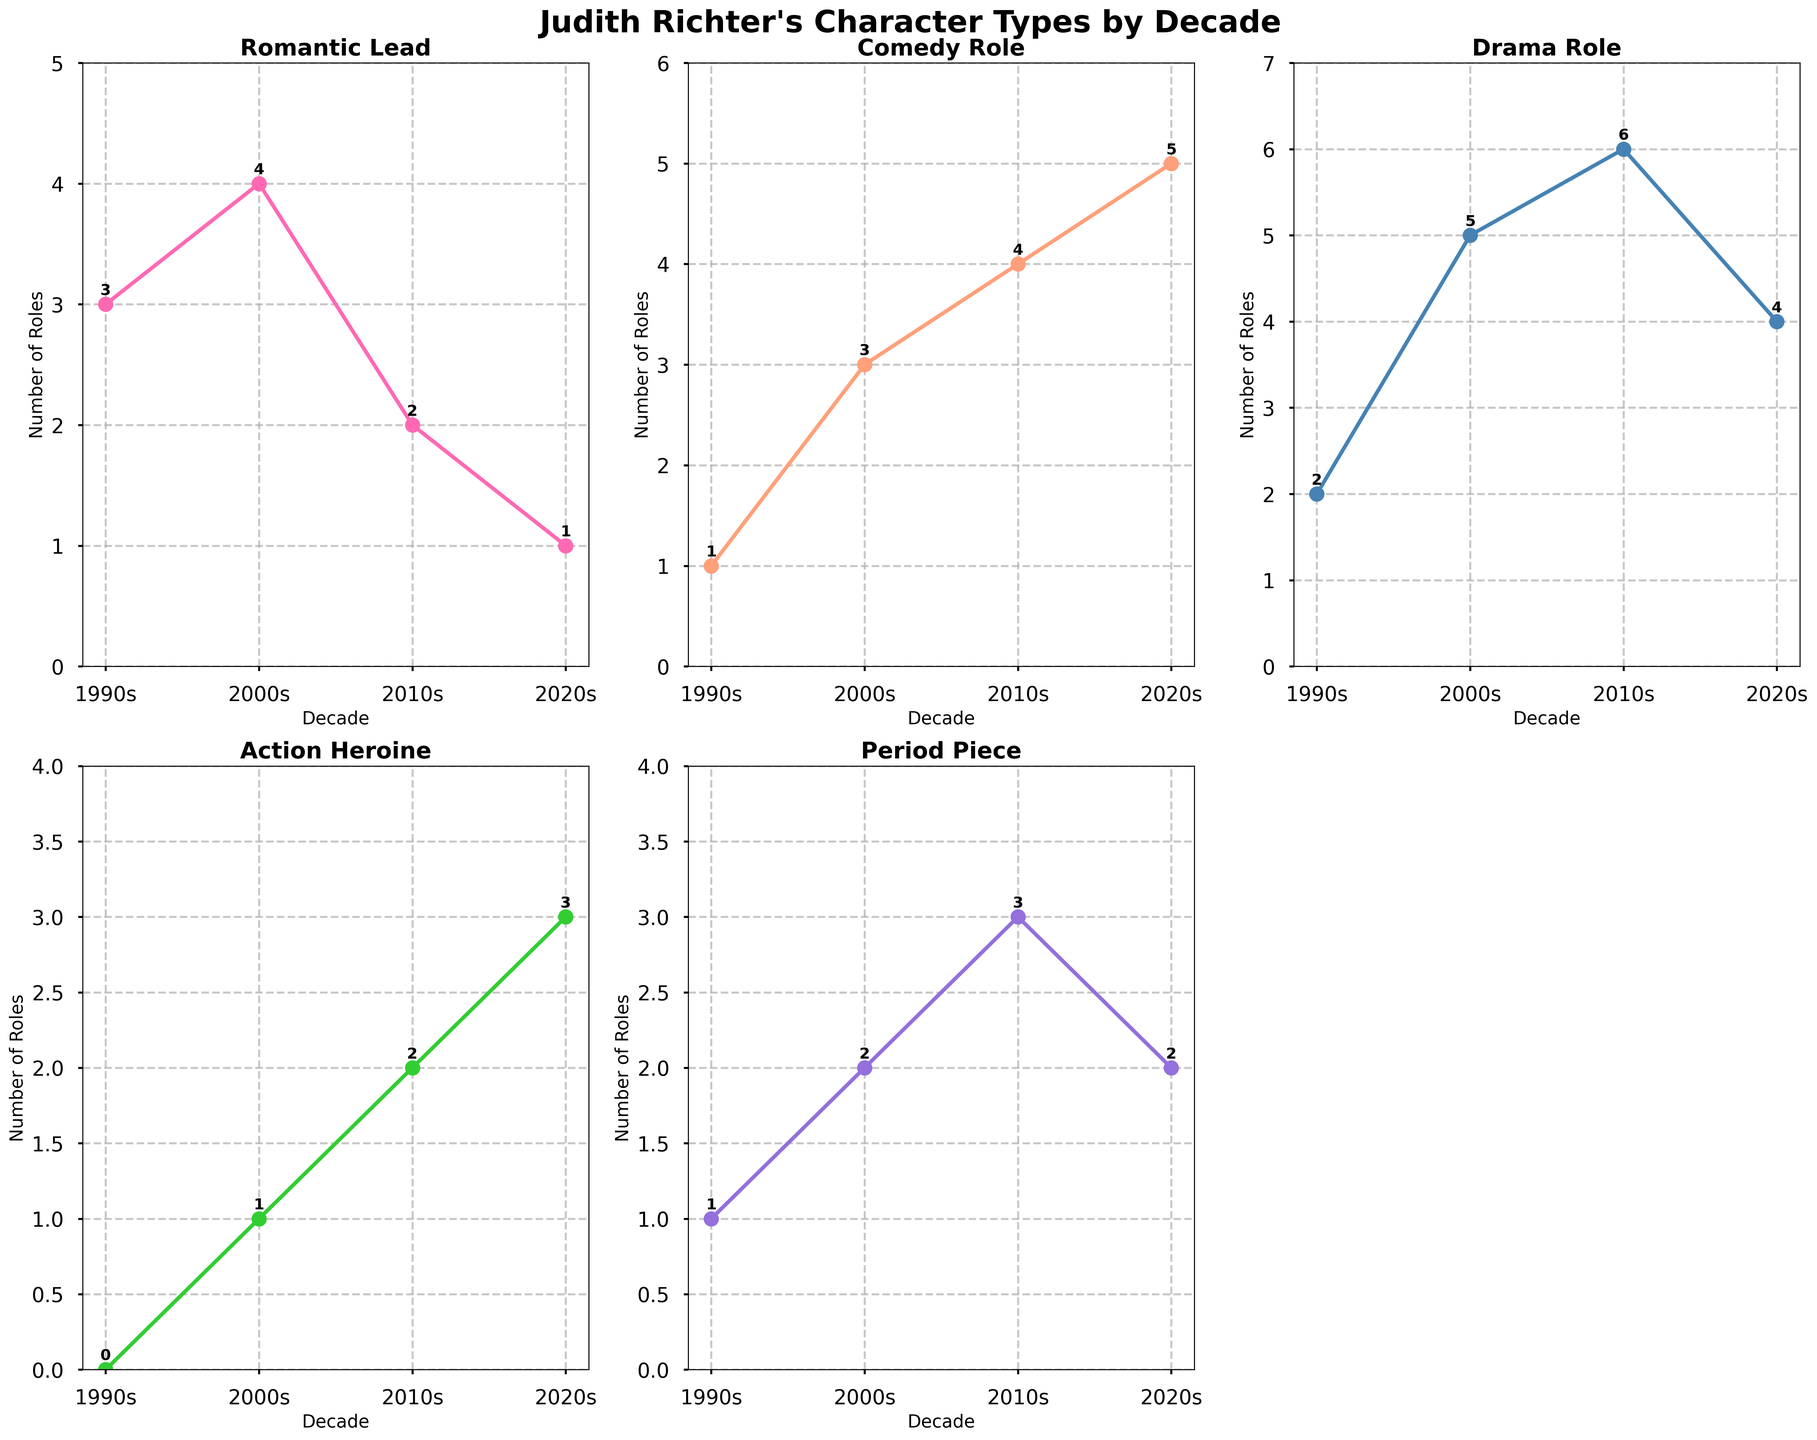What decade had the highest number of Comedy roles? Look at the subplot for Comedy Role and identify the peak. The Comedy Role is highest in the 2020s with 5 roles.
Answer: 2020s How many roles were played by Judith Richter as Action Heroine across all decades? Sum the number of Action Heroine roles: 0 (1990s) + 1 (2000s) + 2 (2010s) + 3 (2020s) = 6.
Answer: 6 In which decade did Judith Richter play the fewest Drama Roles? By looking at the subplot for Drama Role, the least number of Drama Roles are in the 1990s with 2 roles.
Answer: 1990s How did the number of Period Piece roles change from the 2000s to the 2010s? Compare the values from the subplot: 2 (2000s) to 3 (2010s). The number increased by 1.
Answer: Increased by 1 Which character type had the most significant increase from the 1990s to the 2020s? Calculate the difference for each character type from the 1990s to the 2020s and identify the largest: Romantic Lead (1 - 3 = -2), Comedy Role (5 - 1 = 4), Drama Role (4 - 2 = 2), Action Heroine (3 - 0 = 3), Period Piece (2 - 1 = 1). The biggest increase is in Comedy Role with 4.
Answer: Comedy Role What is the average number of Drama Roles per decade? Sum the Drama Roles and divide by the number of decades: (2 + 5 + 6 + 4) / 4 = 17 / 4 = 4.25.
Answer: 4.25 What was the total number of Romantic Lead roles played in the 1990s and 2000s combined? Add the number of Romantic Lead roles for these decades: 3 (1990s) + 4 (2000s) = 7.
Answer: 7 Did the number of roles as a Period Piece character increase or decrease between the 2010s and 2020s? Compare the values from the subplot: 3 (2010s) to 2 (2020s). The number decreased by 1.
Answer: Decreased by 1 Which character type shows the most consistent increase in roles across all decades? Evaluate the trend lines for all character types; Drama Role increases most steadily: 2 (1990s), 5 (2000s), 6 (2010s), 4 (2020s) shows an overall upward trend.
Answer: Drama Role 